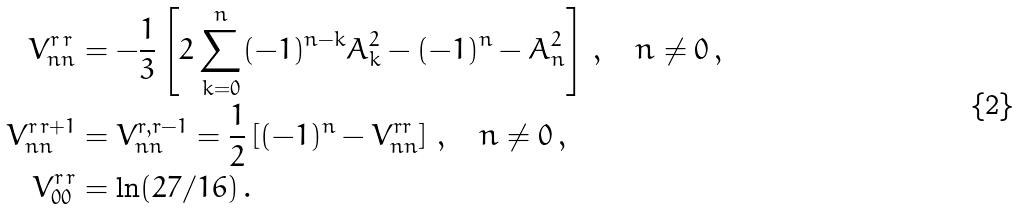Convert formula to latex. <formula><loc_0><loc_0><loc_500><loc_500>V ^ { r \, r } _ { n n } & = - \frac { 1 } { 3 } \left [ 2 \sum _ { k = 0 } ^ { n } ( - 1 ) ^ { n - k } A _ { k } ^ { 2 } - ( - 1 ) ^ { n } - A _ { n } ^ { 2 } \right ] \, , \quad n \ne 0 \, , \\ V ^ { r \, r + 1 } _ { n n } & = V ^ { r , r - 1 } _ { n n } = \frac { 1 } { 2 } \left [ ( - 1 ) ^ { n } - V ^ { r r } _ { n n } \right ] \, , \quad n \ne 0 \, , \\ V ^ { r \, r } _ { 0 0 } & = \ln ( 2 7 / 1 6 ) \, .</formula> 